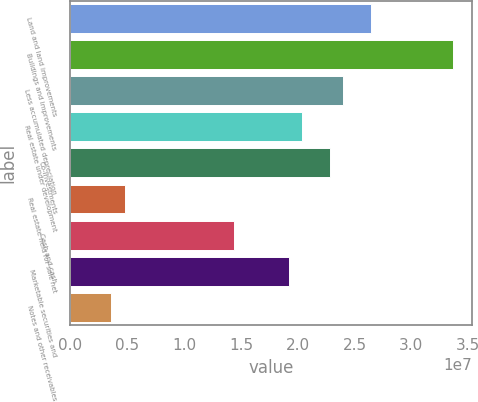Convert chart. <chart><loc_0><loc_0><loc_500><loc_500><bar_chart><fcel>Land and land improvements<fcel>Buildings and improvements<fcel>Less accumulated depreciation<fcel>Real estate under development<fcel>Co-investments<fcel>Real estate held for sale net<fcel>Cash and cash<fcel>Marketable securities and<fcel>Notes and other receivables<nl><fcel>2.64112e+07<fcel>3.36142e+07<fcel>2.40102e+07<fcel>2.04087e+07<fcel>2.28097e+07<fcel>4.80204e+06<fcel>1.44061e+07<fcel>1.92081e+07<fcel>3.60153e+06<nl></chart> 